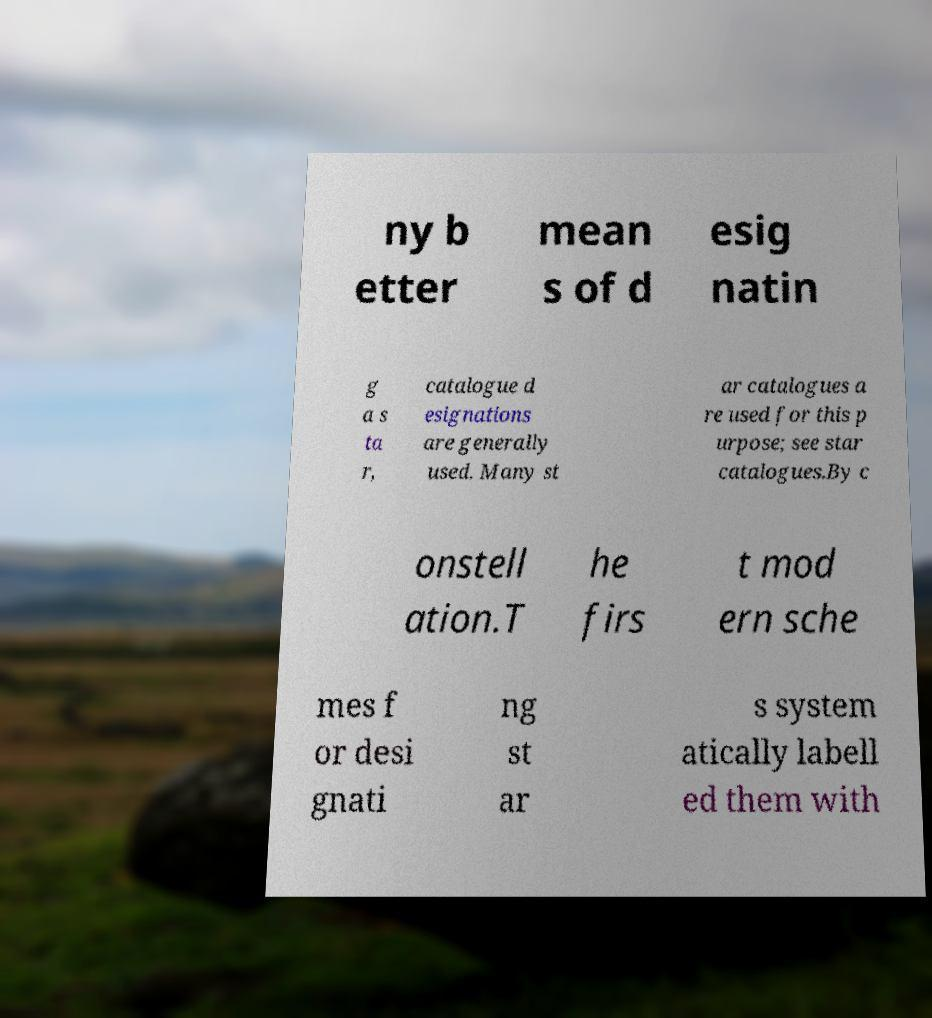Could you assist in decoding the text presented in this image and type it out clearly? ny b etter mean s of d esig natin g a s ta r, catalogue d esignations are generally used. Many st ar catalogues a re used for this p urpose; see star catalogues.By c onstell ation.T he firs t mod ern sche mes f or desi gnati ng st ar s system atically labell ed them with 